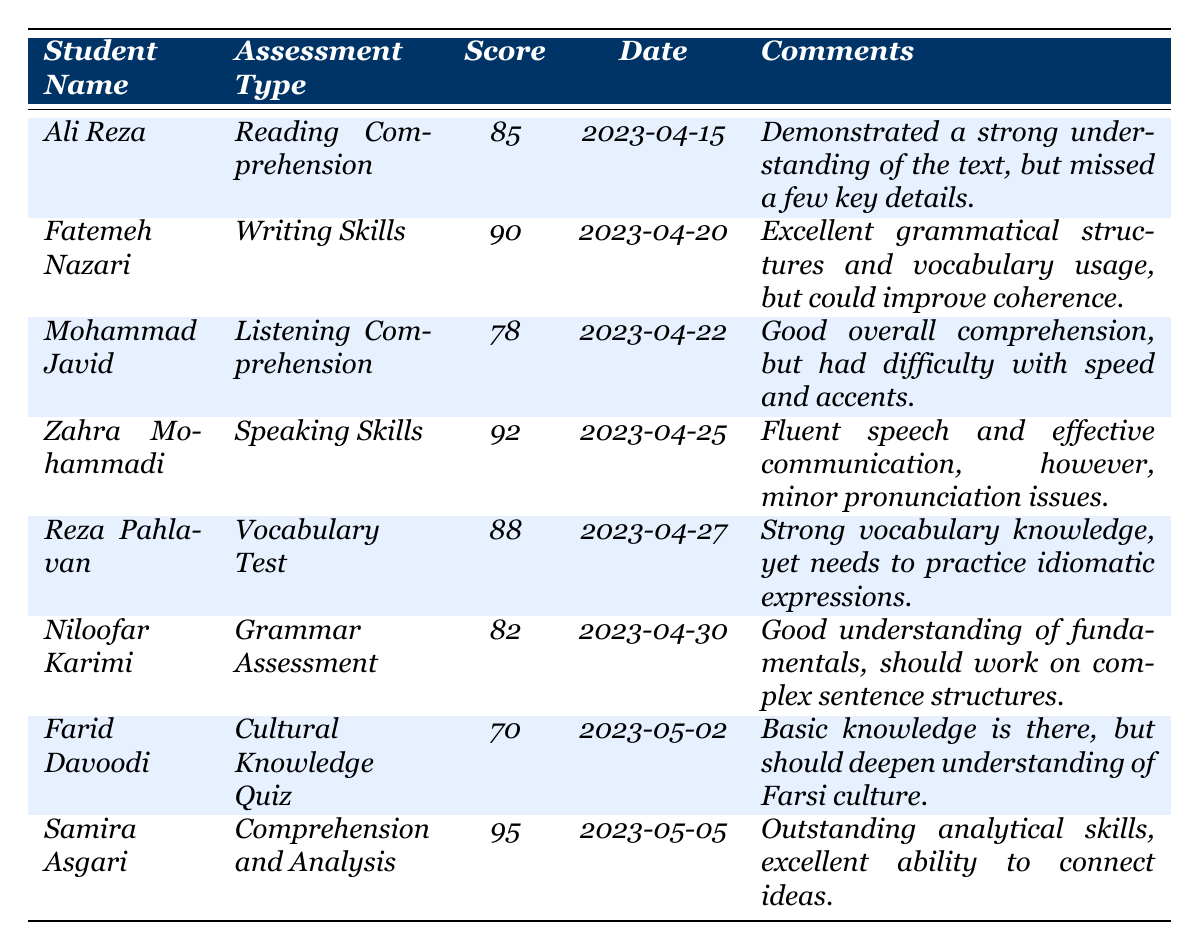What is the highest score among the students? By reviewing the scores listed in the table, we find that the highest score is 95, which belongs to Samira Asgari for the Comprehension and Analysis assessment.
Answer: 95 Which student received a score of 70? Looking at the data, the only student who scored 70 is Farid Davoodi in the Cultural Knowledge Quiz.
Answer: Farid Davoodi What is the average score of the students? To calculate the average, we add all the scores: 85 + 90 + 78 + 92 + 88 + 82 + 70 + 95 = 600. There are 8 students, so the average score is 600 / 8 = 75.
Answer: 75 Did any student score below 80? From the list of scores, Mohammad Javid scored 78, which is below 80.
Answer: Yes Which assessment type had the highest score and what was it? The highest score of 95 was achieved in the Comprehension and Analysis assessment, performed by Samira Asgari.
Answer: Comprehension and Analysis, 95 How many students scored above 85? Only Fatemeh Nazari (90), Zahra Mohammadi (92), Reza Pahlavan (88), and Samira Asgari (95) scored above 85, totaling four students.
Answer: Four students What percentage of students demonstrated a score of 80 or above? Six students scored 80 or above (85, 90, 92, 88, 82, 95) out of eight total students. To find the percentage, it is (6 / 8) * 100 = 75%.
Answer: 75% Compare the scores of Ali Reza and Niloofar Karimi. Who had a better performance? Ali Reza scored 85, while Niloofar Karimi scored 82. Since 85 is greater than 82, Ali Reza performed better.
Answer: Ali Reza What commonality did Fatemeh Nazari and Zahra Mohammadi share in terms of assessment skills? Both students excelled in their respective assessments, with Fatemeh scoring 90 in Writing Skills and Zahra scoring 92 in Speaking Skills, indicating their strengths in expressive components of Farsi.
Answer: They both excelled in their assessments If the students were to be ranked based on their scores, what would be the position of Mohammad Javid? Considering the scores, Mohammad Javid (78) ranks last when students are arranged in descending order: 95, 92, 90, 88, 85, 82, 80, 78. Therefore, he holds the 8th position.
Answer: 8th position 